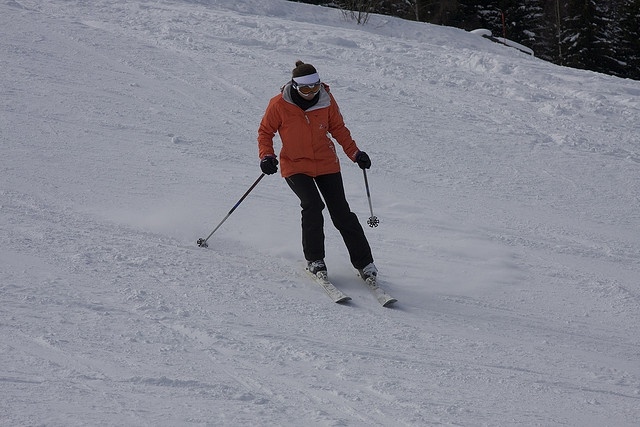Describe the objects in this image and their specific colors. I can see people in gray, black, maroon, and darkgray tones and skis in gray and black tones in this image. 